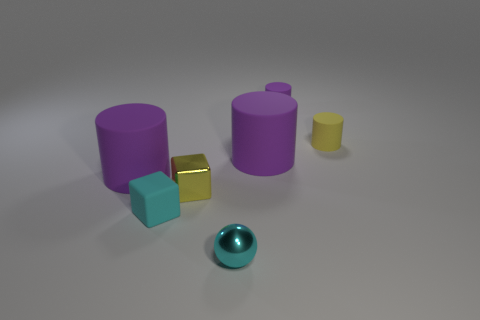There is a tiny sphere that is the same color as the small matte cube; what is its material?
Give a very brief answer. Metal. Does the tiny ball have the same color as the metal block?
Provide a short and direct response. No. What is the material of the yellow thing that is behind the cylinder that is in front of the big thing that is right of the ball?
Keep it short and to the point. Rubber. Are there any large rubber objects to the left of the tiny cyan cube?
Offer a terse response. Yes. What shape is the yellow thing that is the same size as the metal cube?
Provide a succinct answer. Cylinder. Is the material of the small ball the same as the small yellow cube?
Offer a very short reply. Yes. How many shiny things are either purple cylinders or big objects?
Provide a short and direct response. 0. There is a tiny rubber thing that is the same color as the sphere; what is its shape?
Your response must be concise. Cube. There is a matte cylinder that is to the left of the small cyan cube; is it the same color as the matte cube?
Your answer should be very brief. No. There is a large matte thing that is to the right of the big purple rubber cylinder that is on the left side of the cyan cube; what is its shape?
Your response must be concise. Cylinder. 